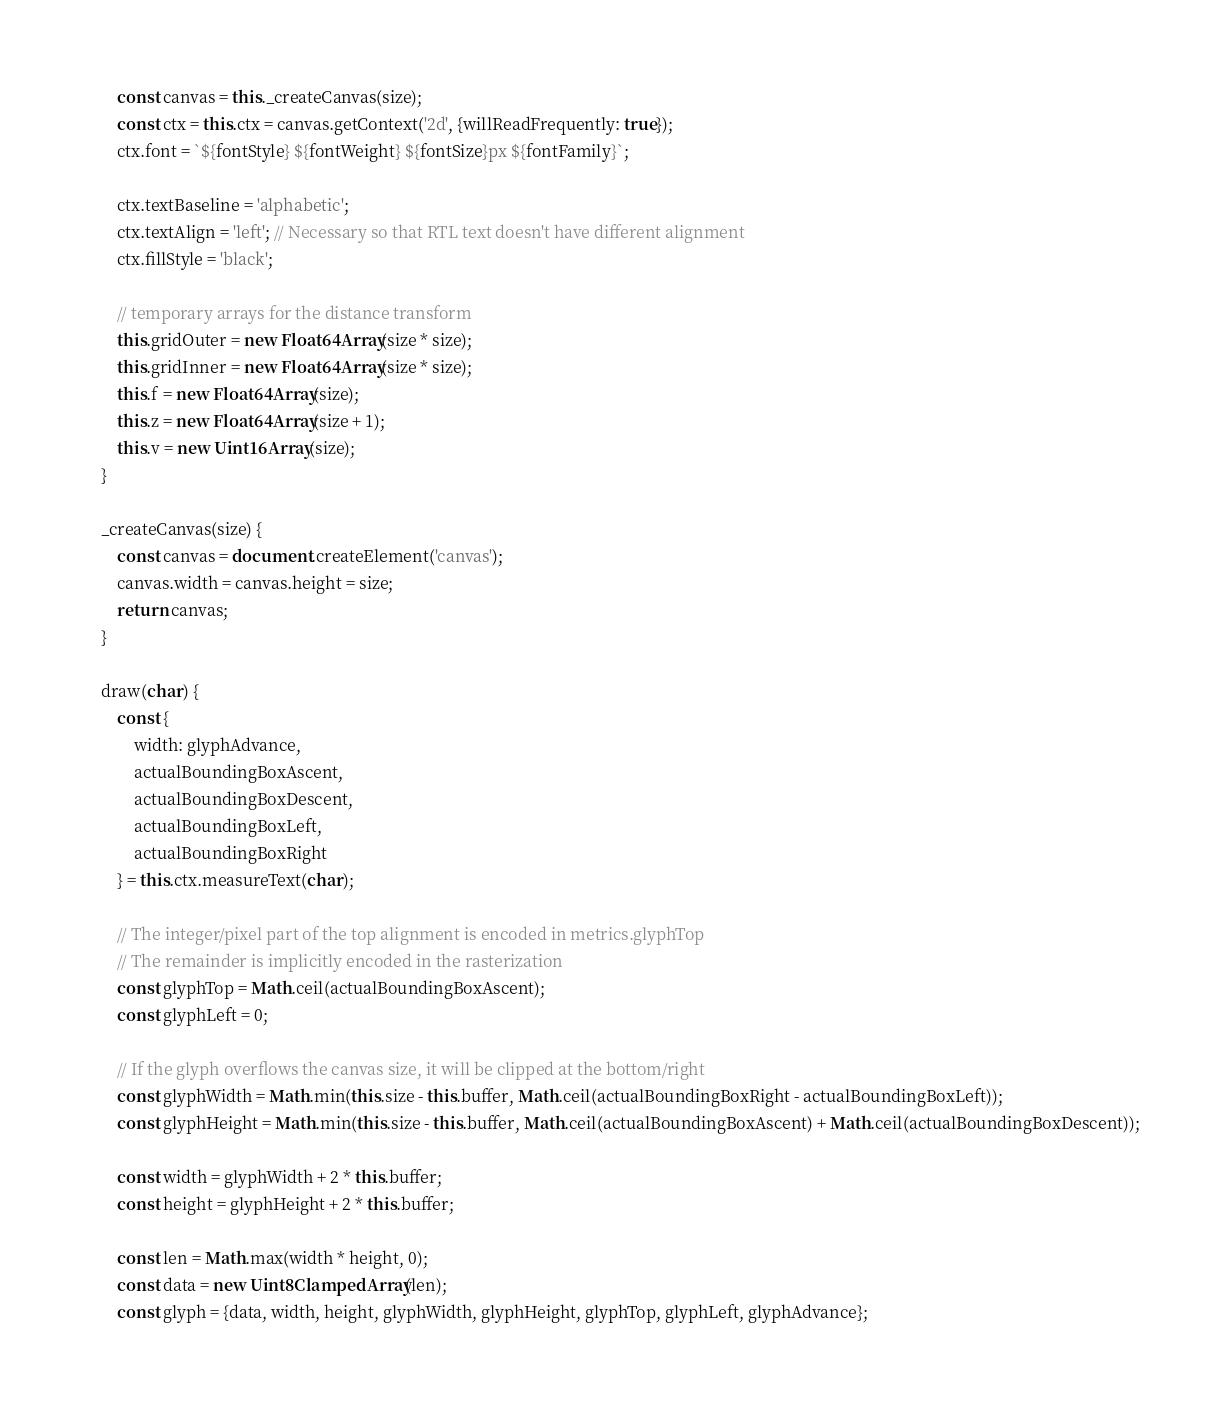<code> <loc_0><loc_0><loc_500><loc_500><_JavaScript_>
        const canvas = this._createCanvas(size);
        const ctx = this.ctx = canvas.getContext('2d', {willReadFrequently: true});
        ctx.font = `${fontStyle} ${fontWeight} ${fontSize}px ${fontFamily}`;

        ctx.textBaseline = 'alphabetic';
        ctx.textAlign = 'left'; // Necessary so that RTL text doesn't have different alignment
        ctx.fillStyle = 'black';

        // temporary arrays for the distance transform
        this.gridOuter = new Float64Array(size * size);
        this.gridInner = new Float64Array(size * size);
        this.f = new Float64Array(size);
        this.z = new Float64Array(size + 1);
        this.v = new Uint16Array(size);
    }

    _createCanvas(size) {
        const canvas = document.createElement('canvas');
        canvas.width = canvas.height = size;
        return canvas;
    }

    draw(char) {
        const {
            width: glyphAdvance,
            actualBoundingBoxAscent,
            actualBoundingBoxDescent,
            actualBoundingBoxLeft,
            actualBoundingBoxRight
        } = this.ctx.measureText(char);

        // The integer/pixel part of the top alignment is encoded in metrics.glyphTop
        // The remainder is implicitly encoded in the rasterization
        const glyphTop = Math.ceil(actualBoundingBoxAscent);
        const glyphLeft = 0;

        // If the glyph overflows the canvas size, it will be clipped at the bottom/right
        const glyphWidth = Math.min(this.size - this.buffer, Math.ceil(actualBoundingBoxRight - actualBoundingBoxLeft));
        const glyphHeight = Math.min(this.size - this.buffer, Math.ceil(actualBoundingBoxAscent) + Math.ceil(actualBoundingBoxDescent));

        const width = glyphWidth + 2 * this.buffer;
        const height = glyphHeight + 2 * this.buffer;

        const len = Math.max(width * height, 0);
        const data = new Uint8ClampedArray(len);
        const glyph = {data, width, height, glyphWidth, glyphHeight, glyphTop, glyphLeft, glyphAdvance};</code> 